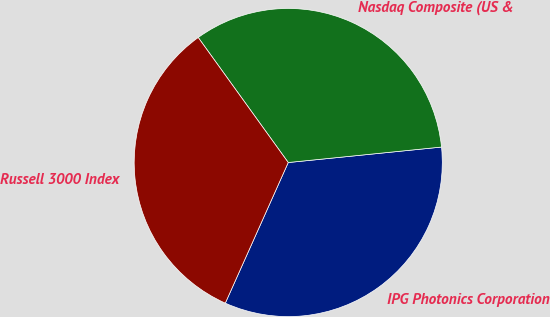<chart> <loc_0><loc_0><loc_500><loc_500><pie_chart><fcel>IPG Photonics Corporation<fcel>Nasdaq Composite (US &<fcel>Russell 3000 Index<nl><fcel>33.3%<fcel>33.33%<fcel>33.37%<nl></chart> 